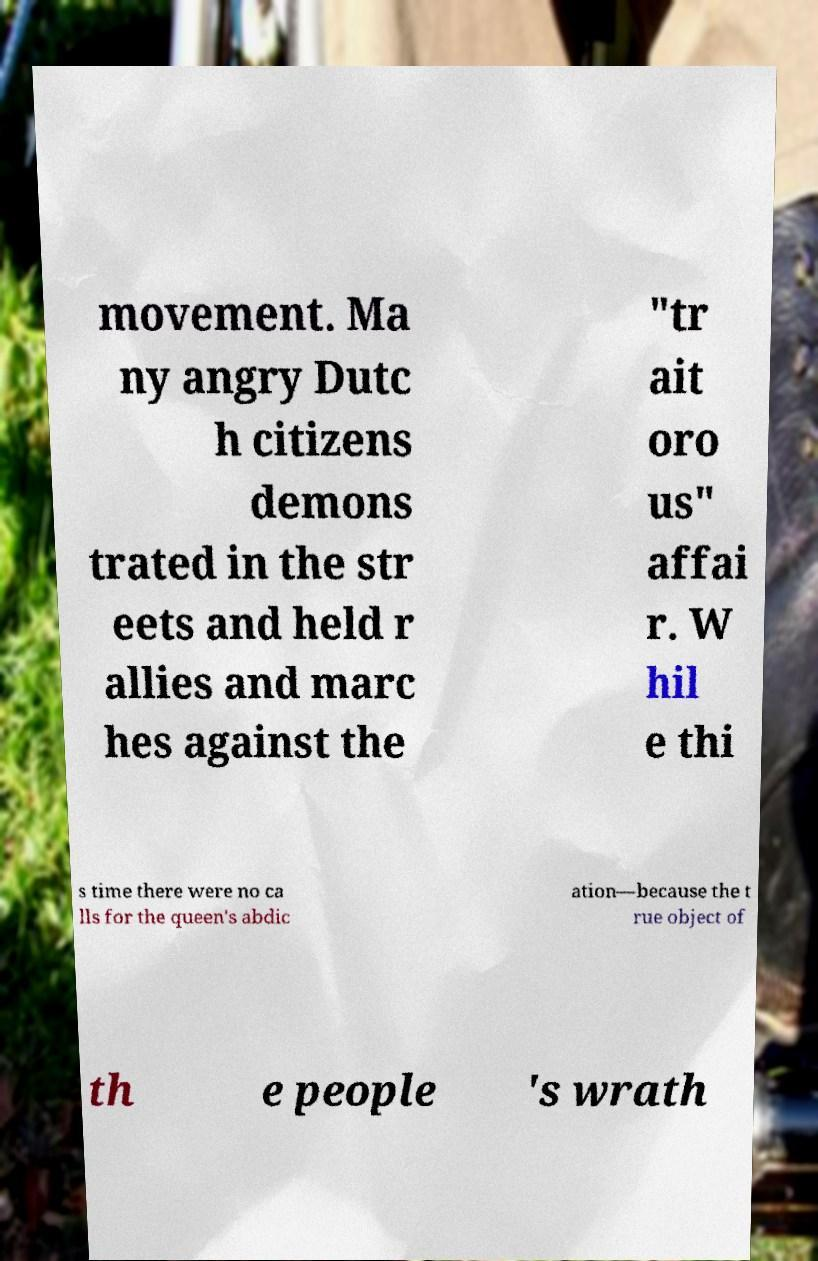What messages or text are displayed in this image? I need them in a readable, typed format. movement. Ma ny angry Dutc h citizens demons trated in the str eets and held r allies and marc hes against the "tr ait oro us" affai r. W hil e thi s time there were no ca lls for the queen's abdic ation—because the t rue object of th e people 's wrath 